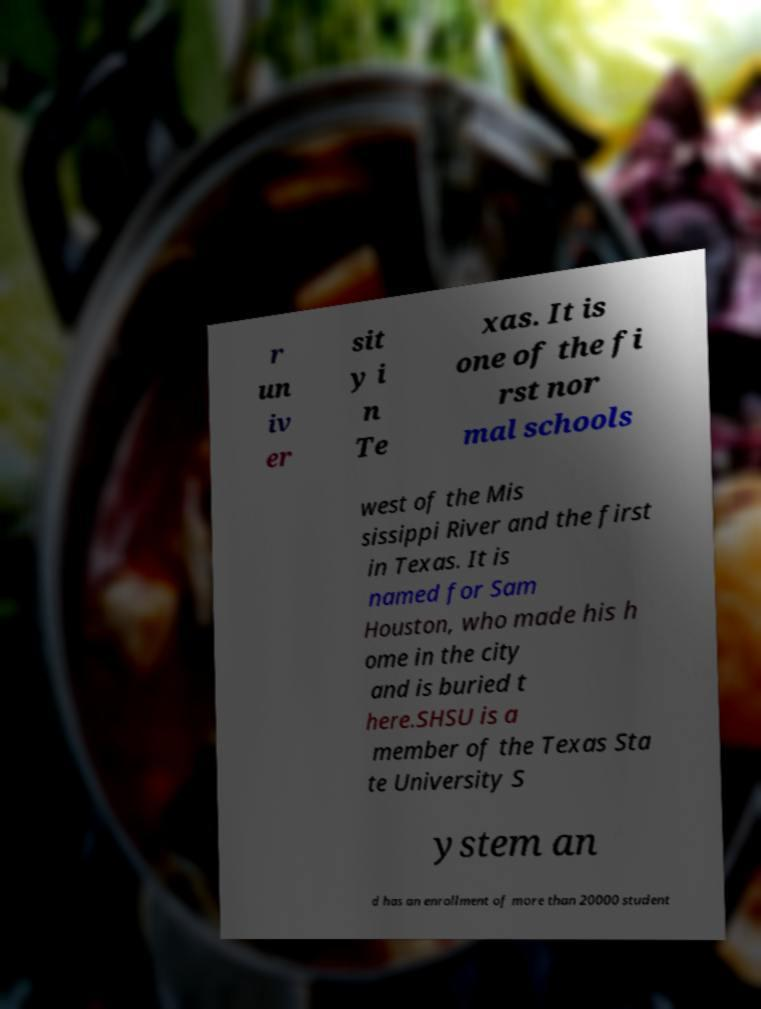Can you accurately transcribe the text from the provided image for me? r un iv er sit y i n Te xas. It is one of the fi rst nor mal schools west of the Mis sissippi River and the first in Texas. It is named for Sam Houston, who made his h ome in the city and is buried t here.SHSU is a member of the Texas Sta te University S ystem an d has an enrollment of more than 20000 student 